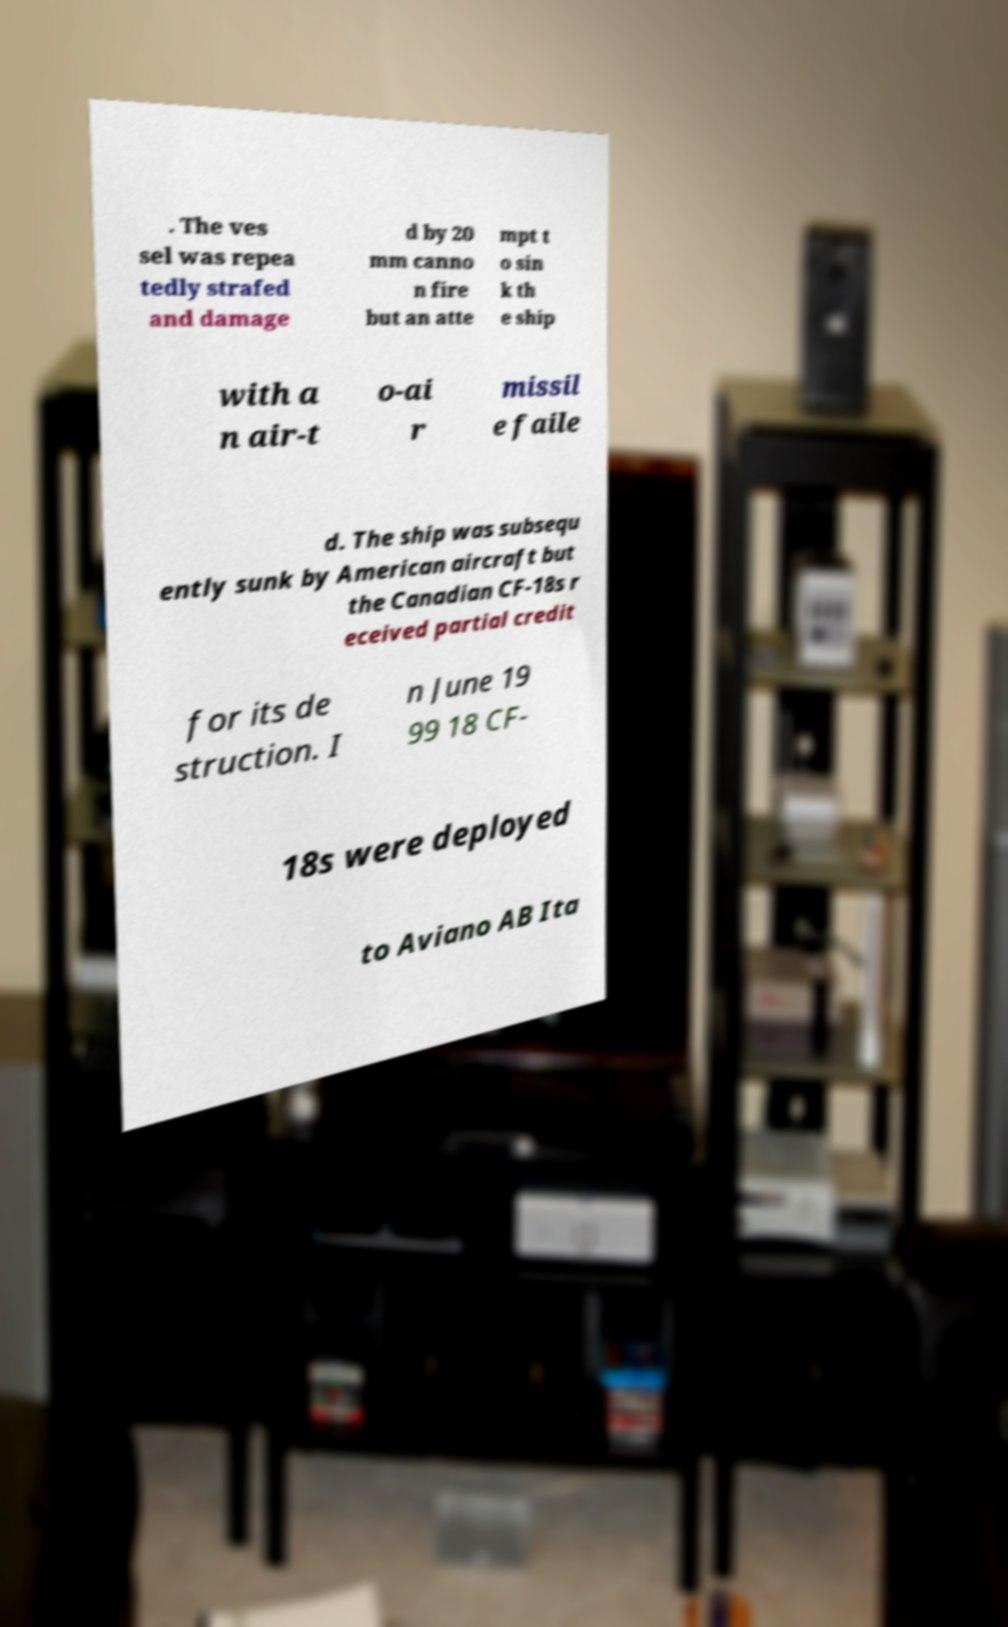Can you read and provide the text displayed in the image?This photo seems to have some interesting text. Can you extract and type it out for me? . The ves sel was repea tedly strafed and damage d by 20 mm canno n fire but an atte mpt t o sin k th e ship with a n air-t o-ai r missil e faile d. The ship was subsequ ently sunk by American aircraft but the Canadian CF-18s r eceived partial credit for its de struction. I n June 19 99 18 CF- 18s were deployed to Aviano AB Ita 